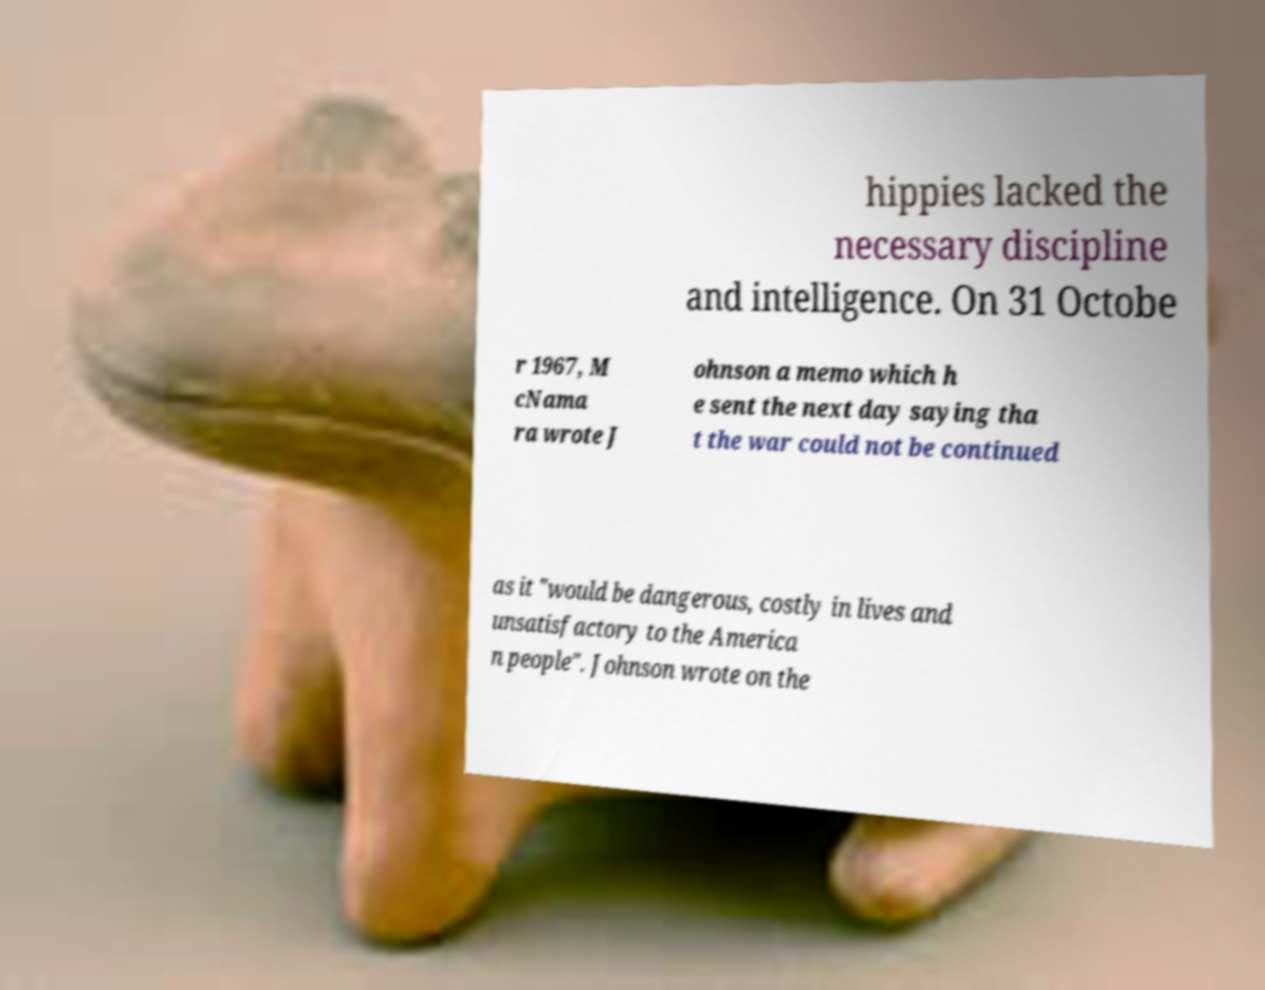Can you accurately transcribe the text from the provided image for me? hippies lacked the necessary discipline and intelligence. On 31 Octobe r 1967, M cNama ra wrote J ohnson a memo which h e sent the next day saying tha t the war could not be continued as it "would be dangerous, costly in lives and unsatisfactory to the America n people". Johnson wrote on the 